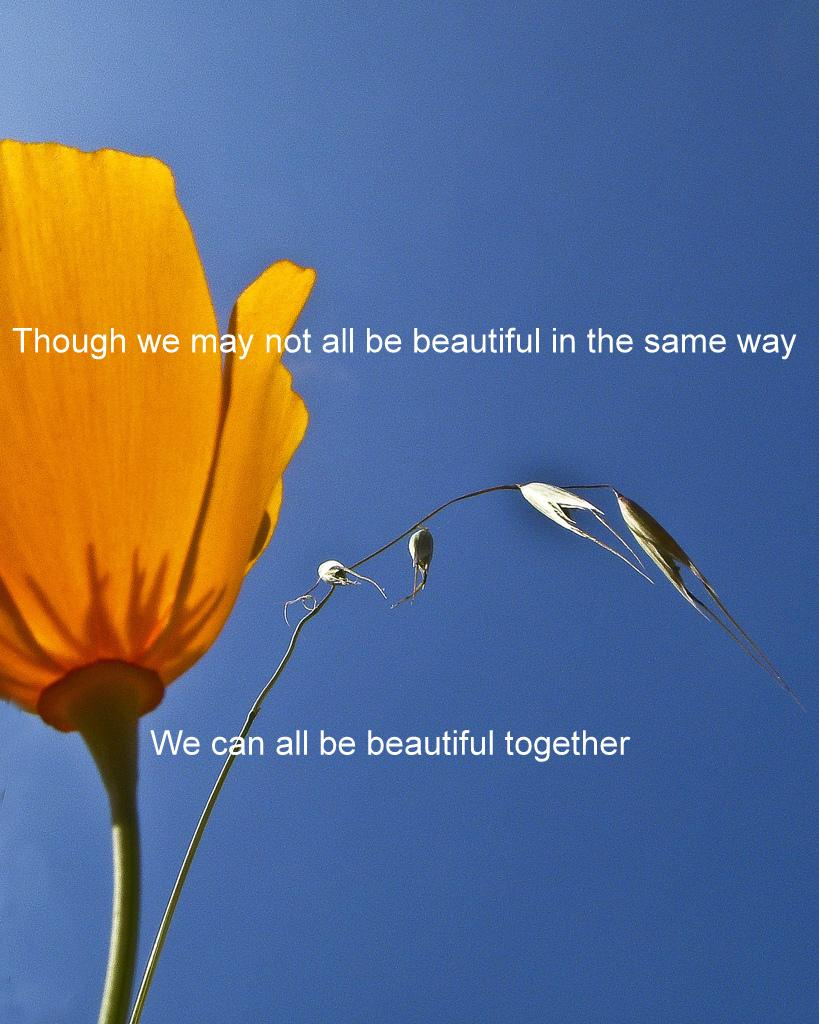What is the main subject in the foreground of the poster? There is a flower in the foreground of the poster. What else can be seen in the foreground of the poster? There are buds in the foreground of the poster. What is featured on the poster besides the flower and buds? There is text on the poster. What is visible at the top of the poster? The sky is visible at the top of the poster. Can you tell me where the goat is located in the poster? There is no goat present in the poster. What type of scarf is draped over the library in the poster? There is no scarf or library present in the poster. 